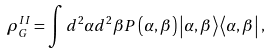<formula> <loc_0><loc_0><loc_500><loc_500>\rho _ { G } ^ { I I } = \int d ^ { 2 } \alpha d ^ { 2 } \beta P \left ( \alpha , \beta \right ) \left | \alpha , \beta \right \rangle \left \langle \alpha , \beta \right | ,</formula> 